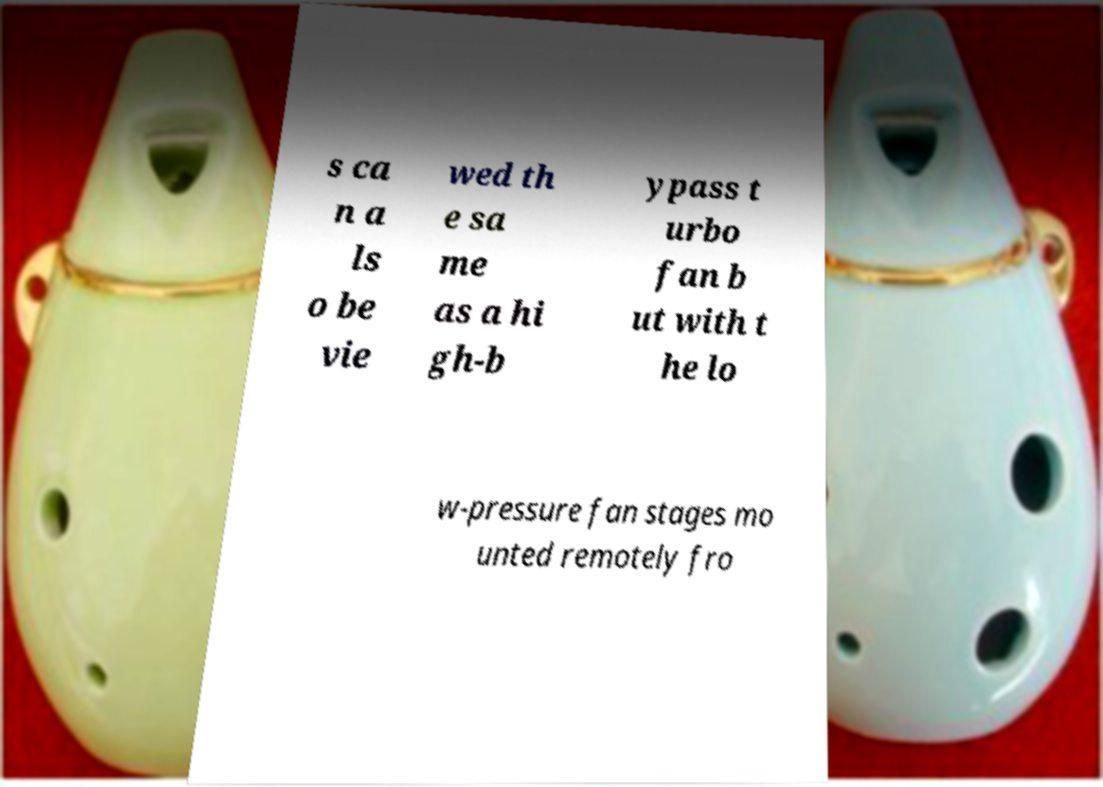Could you assist in decoding the text presented in this image and type it out clearly? s ca n a ls o be vie wed th e sa me as a hi gh-b ypass t urbo fan b ut with t he lo w-pressure fan stages mo unted remotely fro 